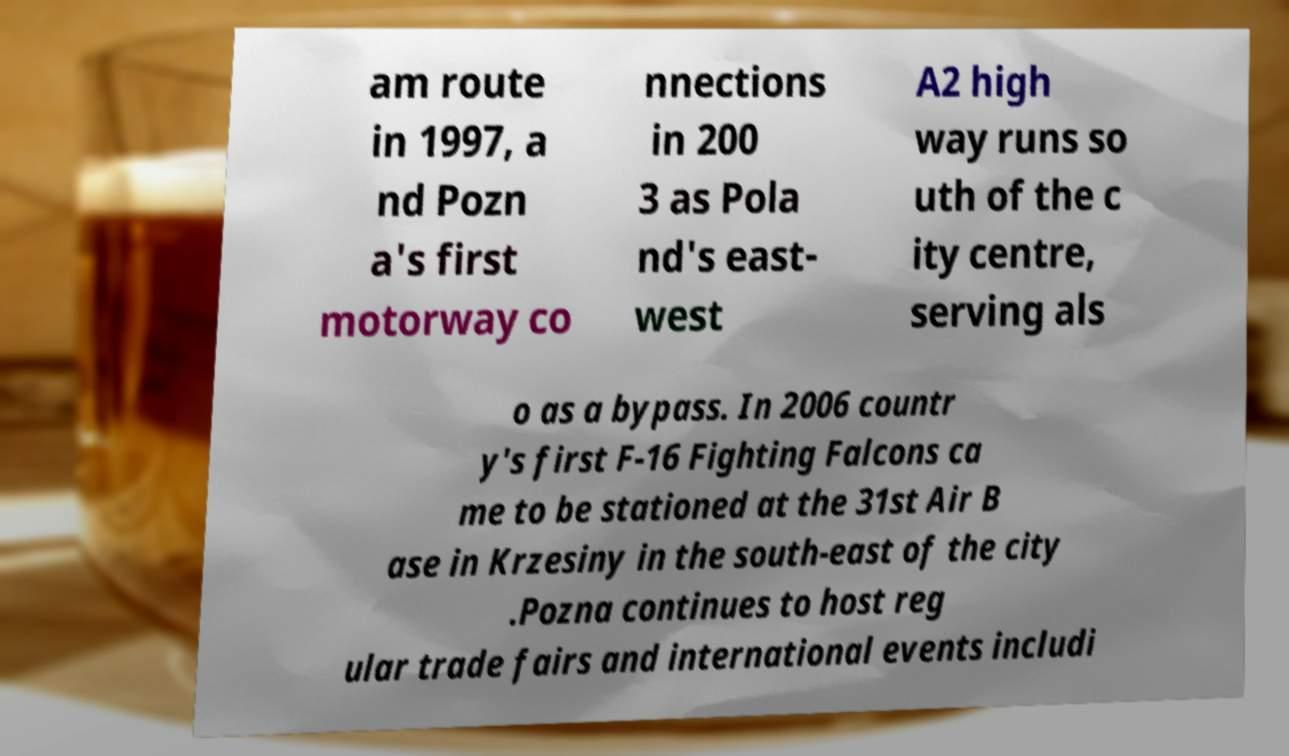Can you accurately transcribe the text from the provided image for me? am route in 1997, a nd Pozn a's first motorway co nnections in 200 3 as Pola nd's east- west A2 high way runs so uth of the c ity centre, serving als o as a bypass. In 2006 countr y's first F-16 Fighting Falcons ca me to be stationed at the 31st Air B ase in Krzesiny in the south-east of the city .Pozna continues to host reg ular trade fairs and international events includi 